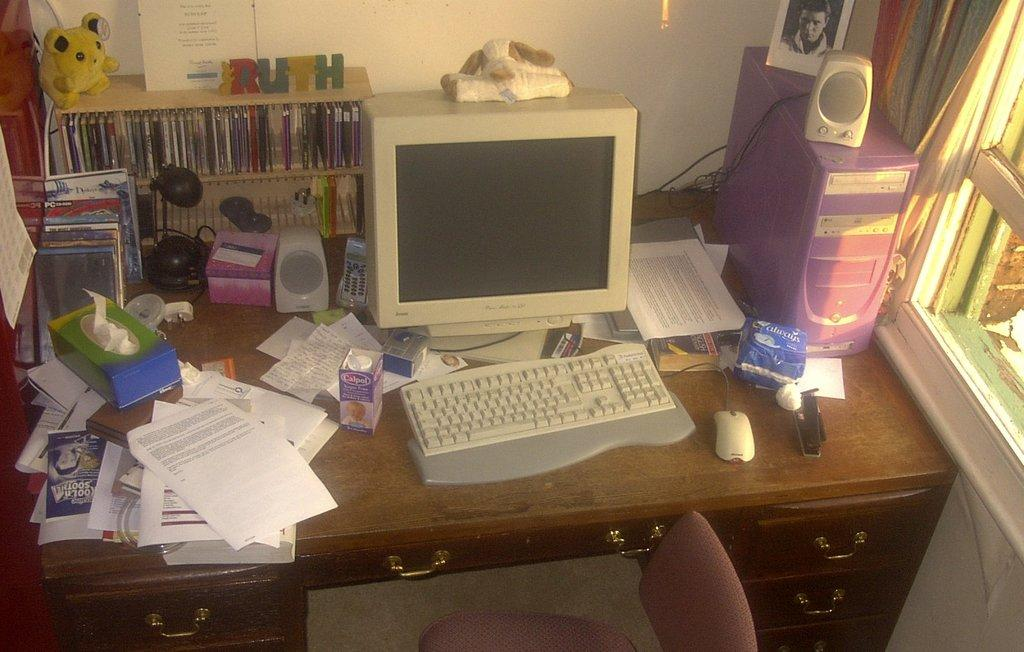<image>
Give a short and clear explanation of the subsequent image. desk with crt monitor and keyboard with a pack of always pads to the right 